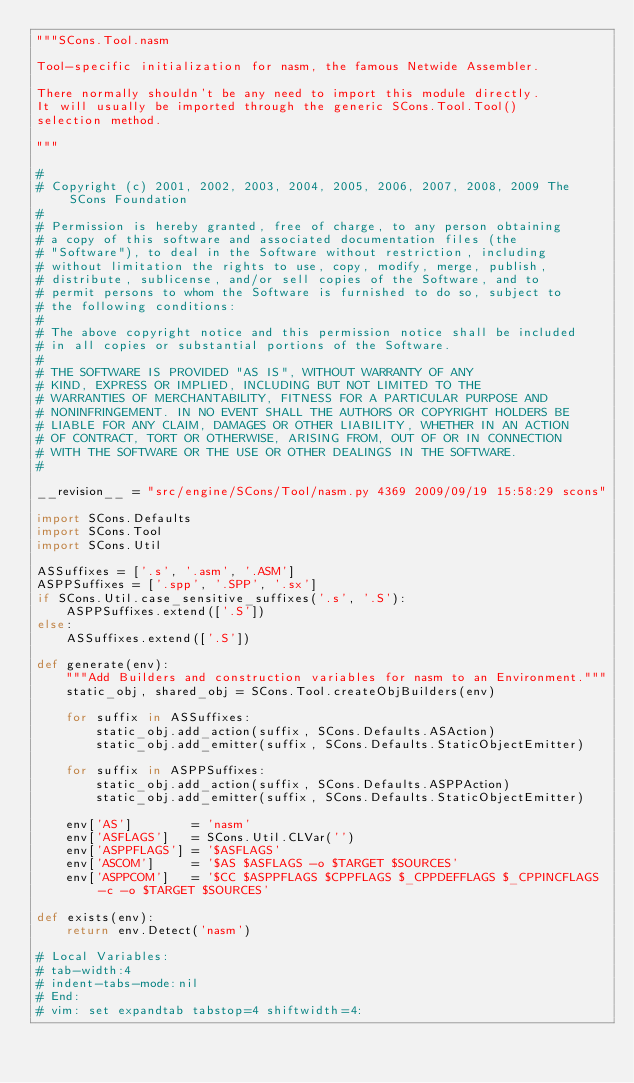Convert code to text. <code><loc_0><loc_0><loc_500><loc_500><_Python_>"""SCons.Tool.nasm

Tool-specific initialization for nasm, the famous Netwide Assembler.

There normally shouldn't be any need to import this module directly.
It will usually be imported through the generic SCons.Tool.Tool()
selection method.

"""

#
# Copyright (c) 2001, 2002, 2003, 2004, 2005, 2006, 2007, 2008, 2009 The SCons Foundation
#
# Permission is hereby granted, free of charge, to any person obtaining
# a copy of this software and associated documentation files (the
# "Software"), to deal in the Software without restriction, including
# without limitation the rights to use, copy, modify, merge, publish,
# distribute, sublicense, and/or sell copies of the Software, and to
# permit persons to whom the Software is furnished to do so, subject to
# the following conditions:
#
# The above copyright notice and this permission notice shall be included
# in all copies or substantial portions of the Software.
#
# THE SOFTWARE IS PROVIDED "AS IS", WITHOUT WARRANTY OF ANY
# KIND, EXPRESS OR IMPLIED, INCLUDING BUT NOT LIMITED TO THE
# WARRANTIES OF MERCHANTABILITY, FITNESS FOR A PARTICULAR PURPOSE AND
# NONINFRINGEMENT. IN NO EVENT SHALL THE AUTHORS OR COPYRIGHT HOLDERS BE
# LIABLE FOR ANY CLAIM, DAMAGES OR OTHER LIABILITY, WHETHER IN AN ACTION
# OF CONTRACT, TORT OR OTHERWISE, ARISING FROM, OUT OF OR IN CONNECTION
# WITH THE SOFTWARE OR THE USE OR OTHER DEALINGS IN THE SOFTWARE.
#

__revision__ = "src/engine/SCons/Tool/nasm.py 4369 2009/09/19 15:58:29 scons"

import SCons.Defaults
import SCons.Tool
import SCons.Util

ASSuffixes = ['.s', '.asm', '.ASM']
ASPPSuffixes = ['.spp', '.SPP', '.sx']
if SCons.Util.case_sensitive_suffixes('.s', '.S'):
    ASPPSuffixes.extend(['.S'])
else:
    ASSuffixes.extend(['.S'])

def generate(env):
    """Add Builders and construction variables for nasm to an Environment."""
    static_obj, shared_obj = SCons.Tool.createObjBuilders(env)

    for suffix in ASSuffixes:
        static_obj.add_action(suffix, SCons.Defaults.ASAction)
        static_obj.add_emitter(suffix, SCons.Defaults.StaticObjectEmitter)

    for suffix in ASPPSuffixes:
        static_obj.add_action(suffix, SCons.Defaults.ASPPAction)
        static_obj.add_emitter(suffix, SCons.Defaults.StaticObjectEmitter)

    env['AS']        = 'nasm'
    env['ASFLAGS']   = SCons.Util.CLVar('')
    env['ASPPFLAGS'] = '$ASFLAGS'
    env['ASCOM']     = '$AS $ASFLAGS -o $TARGET $SOURCES'
    env['ASPPCOM']   = '$CC $ASPPFLAGS $CPPFLAGS $_CPPDEFFLAGS $_CPPINCFLAGS -c -o $TARGET $SOURCES'

def exists(env):
    return env.Detect('nasm')

# Local Variables:
# tab-width:4
# indent-tabs-mode:nil
# End:
# vim: set expandtab tabstop=4 shiftwidth=4:
</code> 